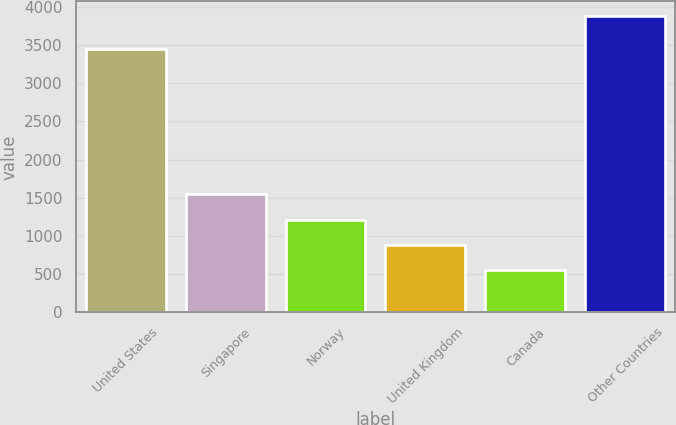Convert chart to OTSL. <chart><loc_0><loc_0><loc_500><loc_500><bar_chart><fcel>United States<fcel>Singapore<fcel>Norway<fcel>United Kingdom<fcel>Canada<fcel>Other Countries<nl><fcel>3444<fcel>1549<fcel>1216<fcel>883<fcel>550<fcel>3880<nl></chart> 